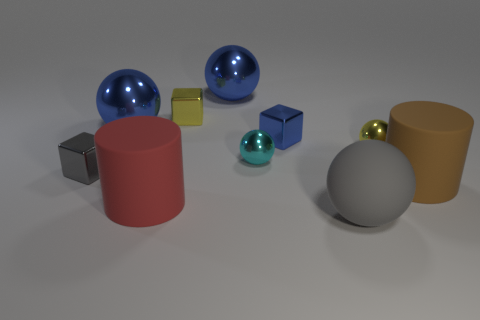Subtract all cyan balls. How many balls are left? 4 Subtract all purple spheres. Subtract all yellow cylinders. How many spheres are left? 5 Subtract all blocks. How many objects are left? 7 Subtract all large green matte things. Subtract all gray metal objects. How many objects are left? 9 Add 3 small cyan things. How many small cyan things are left? 4 Add 9 small purple shiny cubes. How many small purple shiny cubes exist? 9 Subtract 1 yellow cubes. How many objects are left? 9 